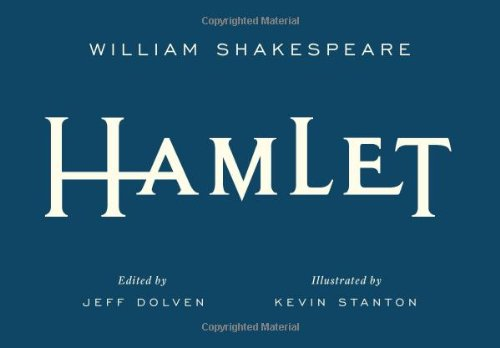What influence has "Hamlet" had on modern literature? Hamlet has had a significant influence on modern literature, offering a rich source of inspiration for discussions on human nature, psychological depth, and narrative complexity. Can you give an example of how 'Hamlet' has influenced other writers or works? Certainly! 'Hamlet' has influenced numerous works, including the novel 'The Catcher in the Rye' by J.D. Salinger, where the protagonist, Holden Caulfield, frequently alludes to the character Hamlet in his reflections on the world around him. 